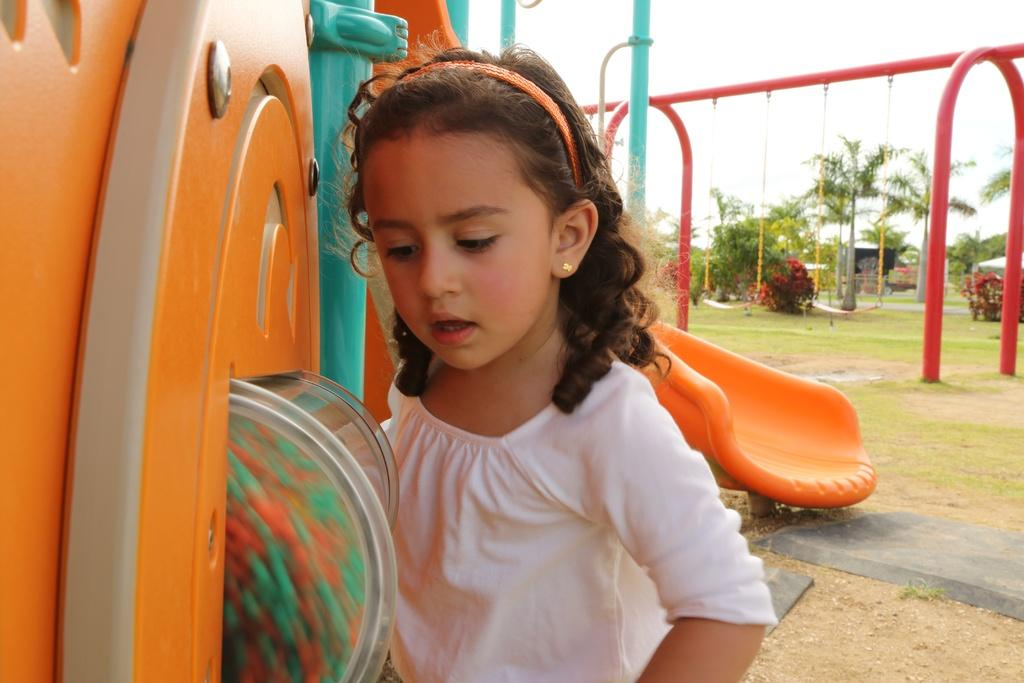What type of location is shown in the image? The image depicts a park. What can be seen in the park that might be used for playing? There are playing objects in the image. What part of the natural environment is visible in the image? The sky is visible in the image. Are there any people present in the image? Yes, there is a girl in the image. What type of society can be seen in the image? There is no specific society depicted in the image; it shows a park with playing objects and a girl. Are there any icicles present in the image? There are no icicles visible in the image, as the sky is clear and the scene appears to be during a warm or temperate time of year. 